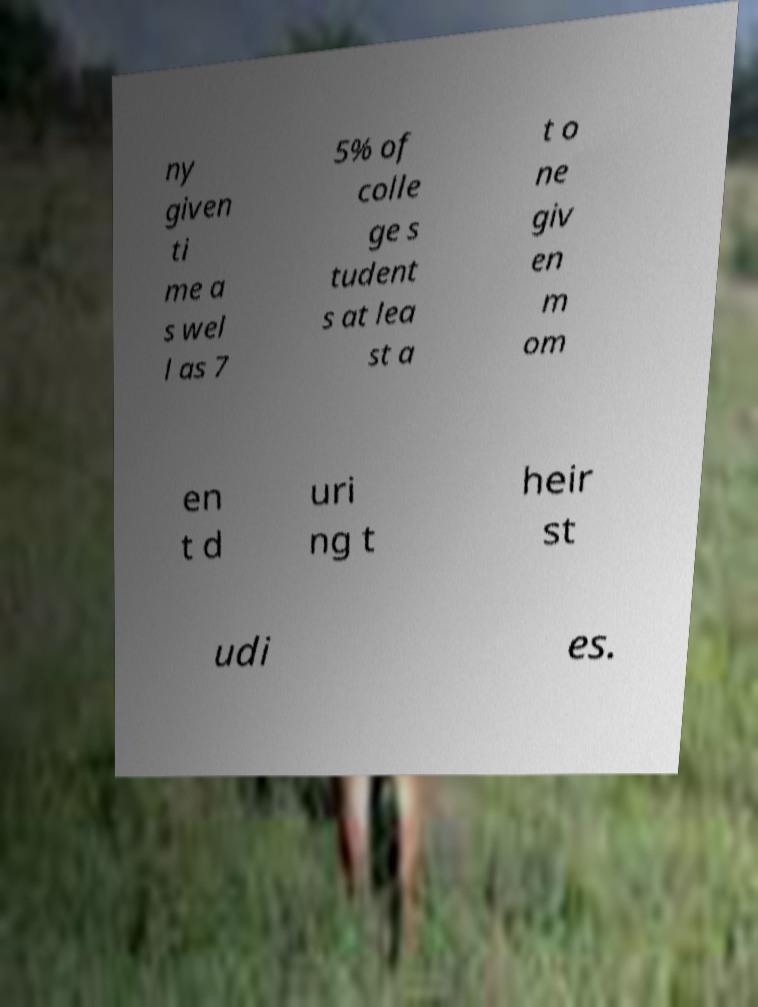Can you accurately transcribe the text from the provided image for me? ny given ti me a s wel l as 7 5% of colle ge s tudent s at lea st a t o ne giv en m om en t d uri ng t heir st udi es. 